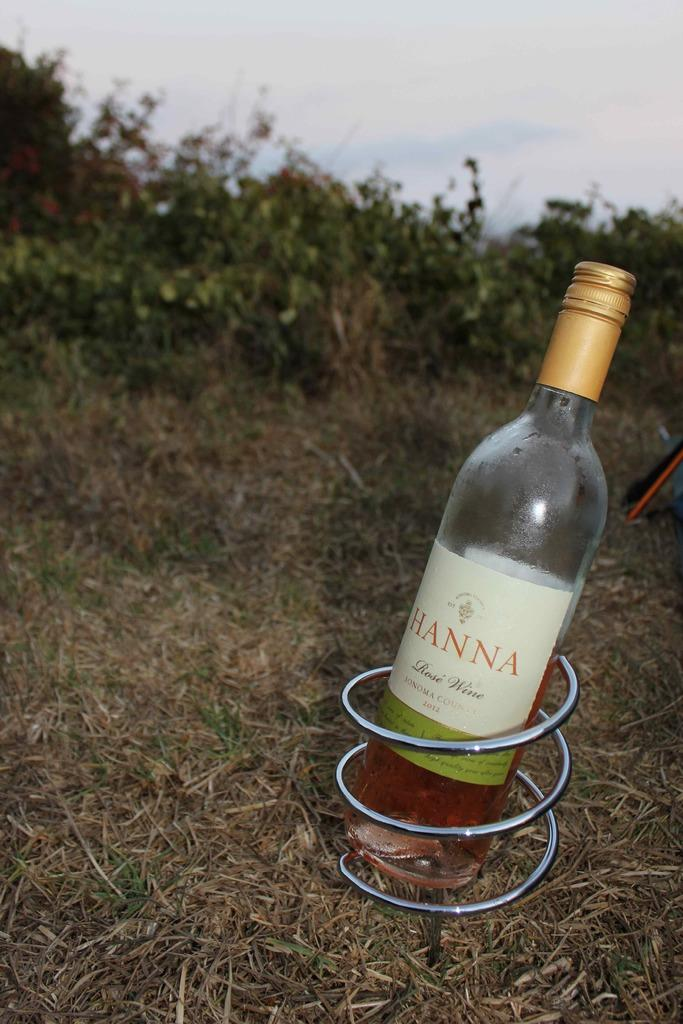<image>
Provide a brief description of the given image. A bottle of wine in a spiral holder, it has the word Hanna on the front. 